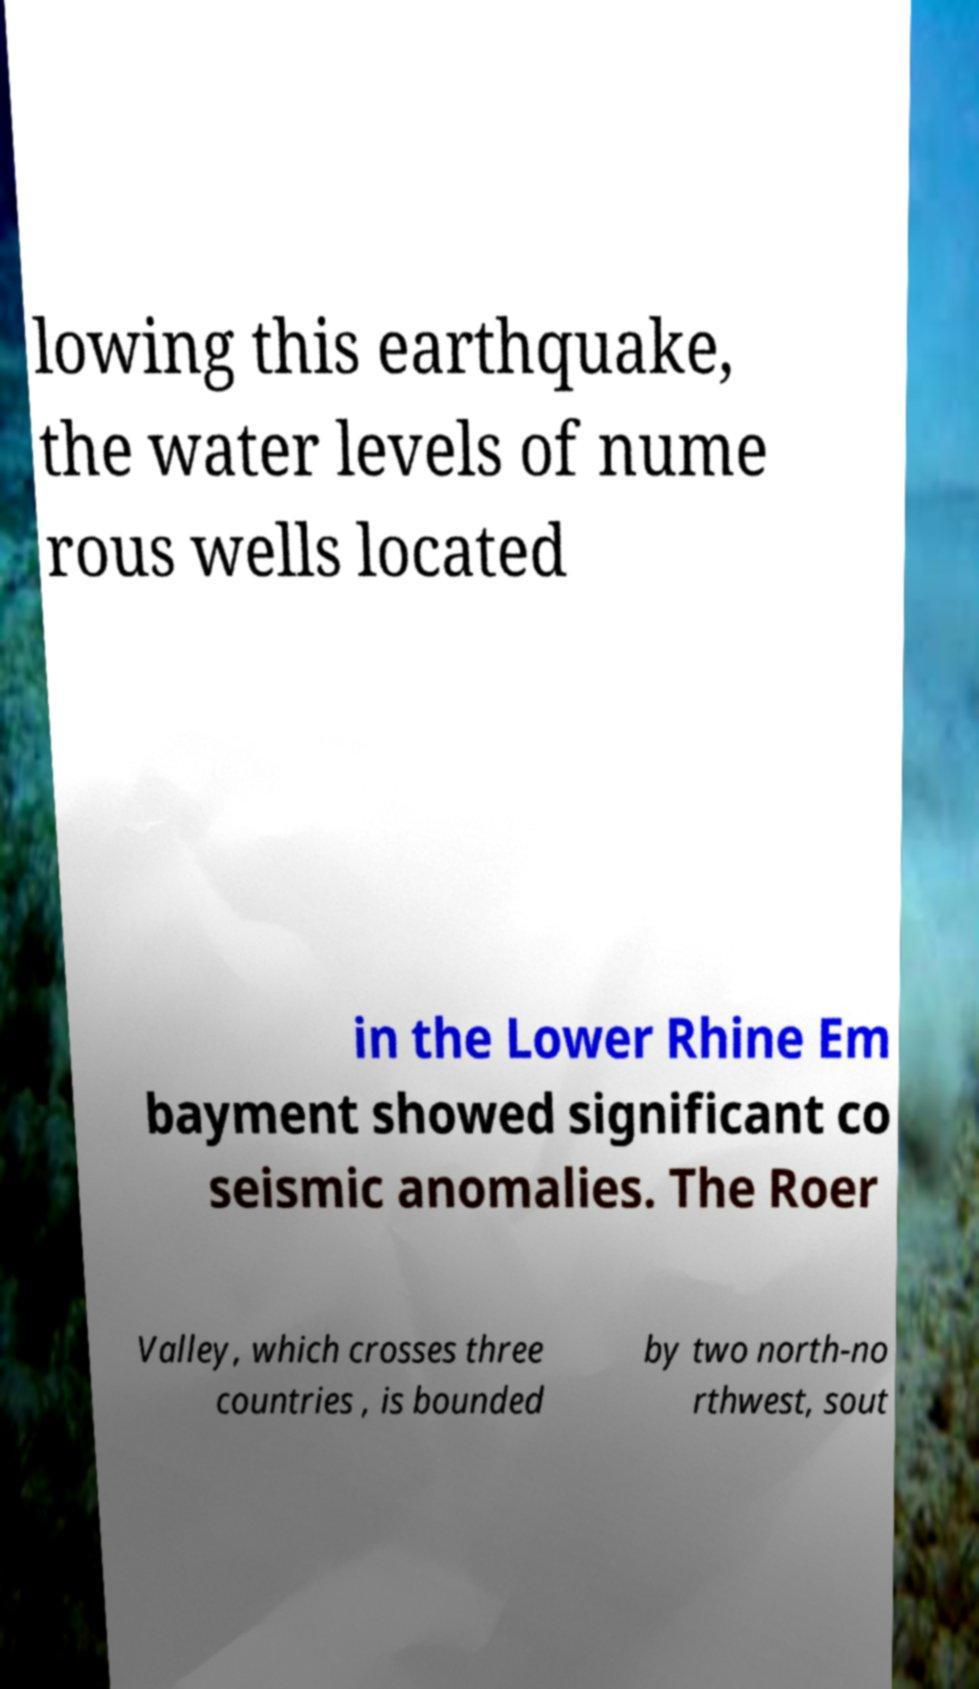Please read and relay the text visible in this image. What does it say? lowing this earthquake, the water levels of nume rous wells located in the Lower Rhine Em bayment showed significant co seismic anomalies. The Roer Valley, which crosses three countries , is bounded by two north-no rthwest, sout 